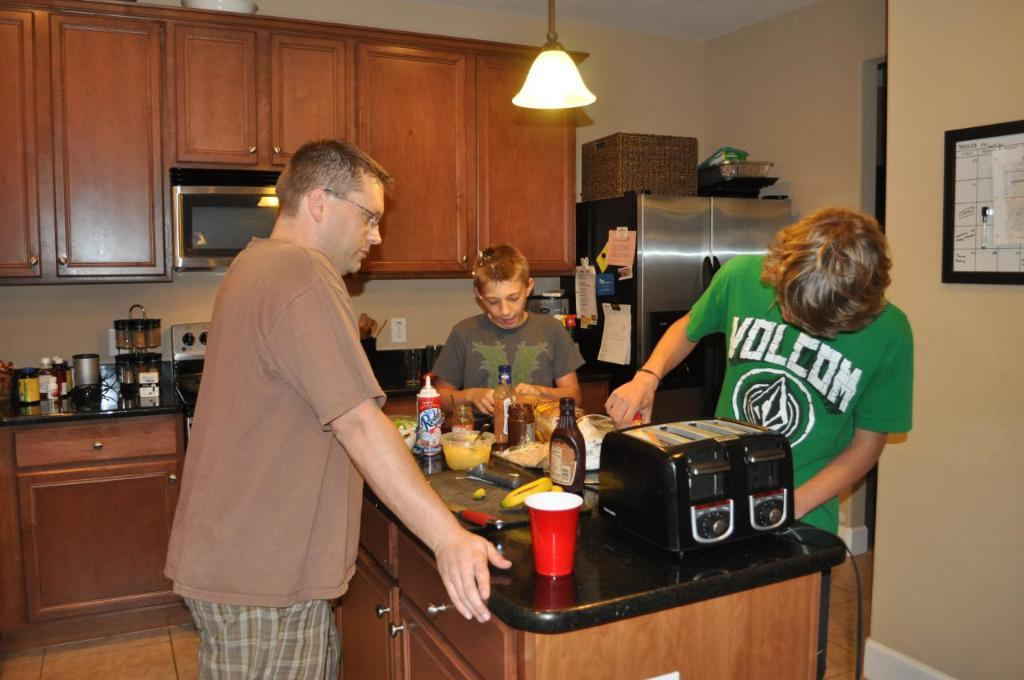<image>
Write a terse but informative summary of the picture. a boy in green wearing a Volcom shirt 